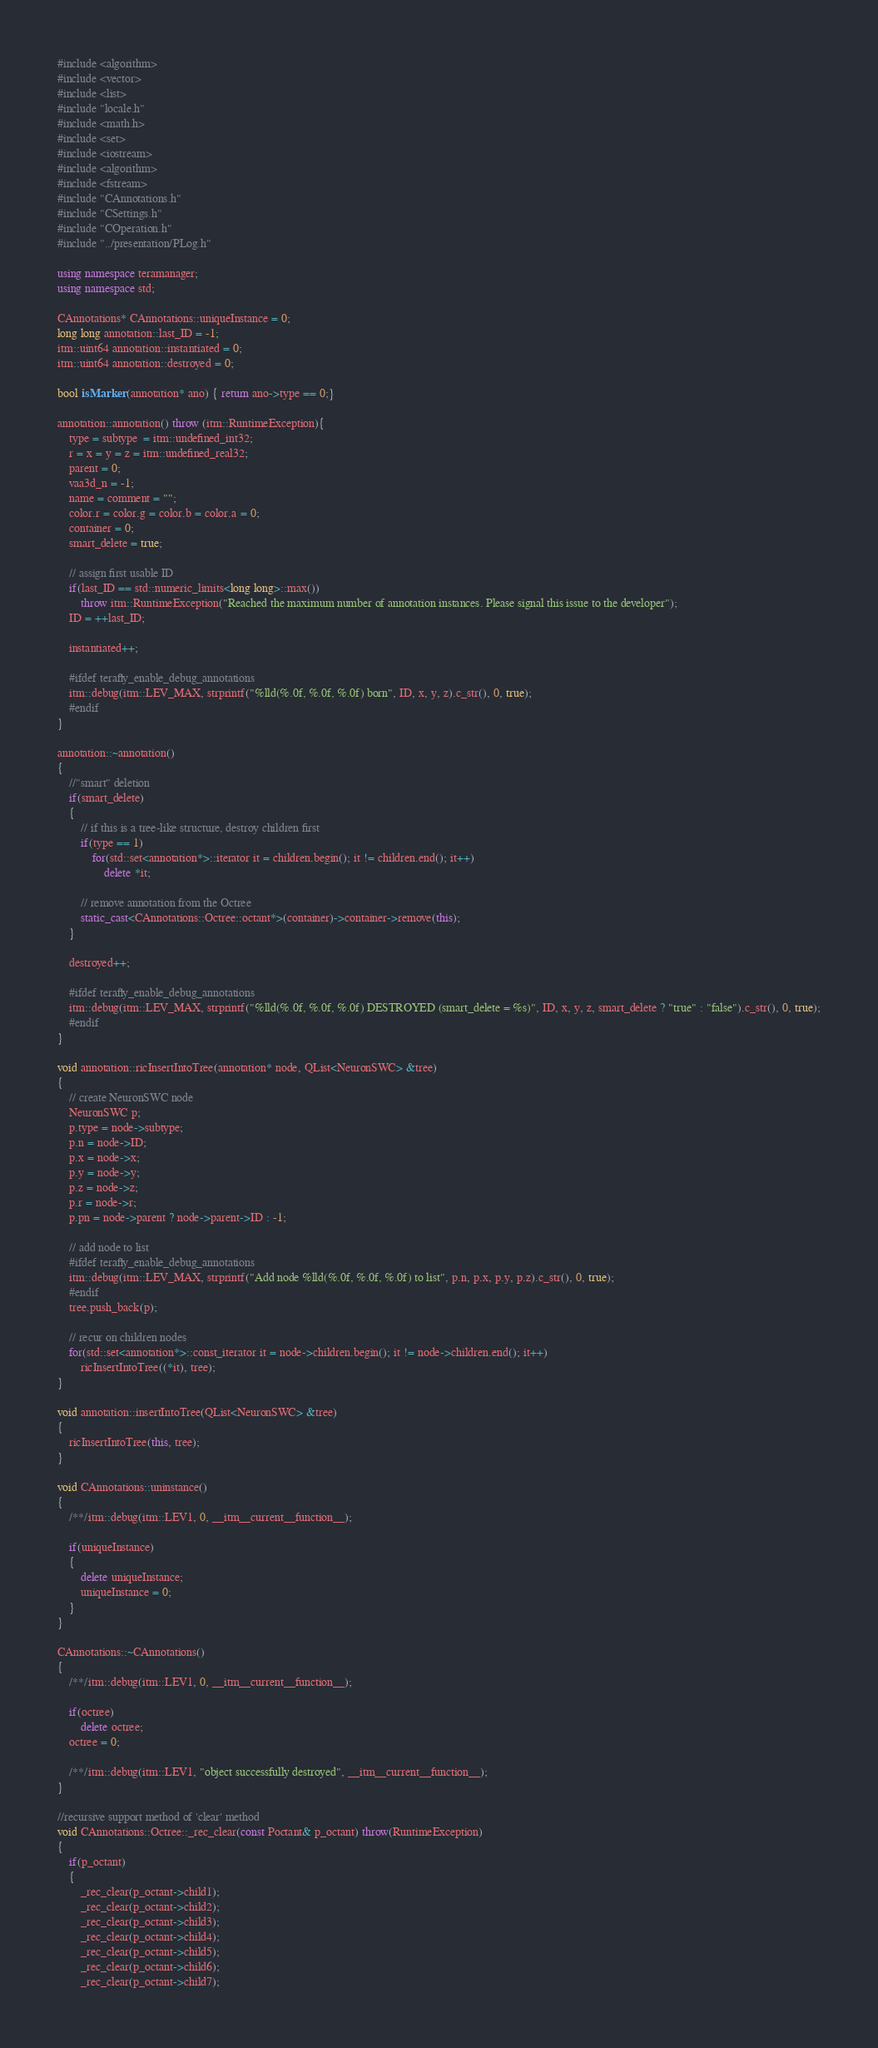<code> <loc_0><loc_0><loc_500><loc_500><_C++_>#include <algorithm>
#include <vector>
#include <list>
#include "locale.h"
#include <math.h>
#include <set>
#include <iostream>
#include <algorithm>
#include <fstream>
#include "CAnnotations.h"
#include "CSettings.h"
#include "COperation.h"
#include "../presentation/PLog.h"

using namespace teramanager;
using namespace std;

CAnnotations* CAnnotations::uniqueInstance = 0;
long long annotation::last_ID = -1;
itm::uint64 annotation::instantiated = 0;
itm::uint64 annotation::destroyed = 0;

bool isMarker (annotation* ano) { return ano->type == 0;}

annotation::annotation() throw (itm::RuntimeException){
    type = subtype  = itm::undefined_int32;
    r = x = y = z = itm::undefined_real32;
    parent = 0;
    vaa3d_n = -1;
    name = comment = "";
    color.r = color.g = color.b = color.a = 0;
    container = 0;
    smart_delete = true;

    // assign first usable ID
    if(last_ID == std::numeric_limits<long long>::max())
        throw itm::RuntimeException("Reached the maximum number of annotation instances. Please signal this issue to the developer");
    ID = ++last_ID;

    instantiated++;

    #ifdef terafly_enable_debug_annotations
    itm::debug(itm::LEV_MAX, strprintf("%lld(%.0f, %.0f, %.0f) born", ID, x, y, z).c_str(), 0, true);
    #endif
}

annotation::~annotation()
{
    //"smart" deletion
    if(smart_delete)
    {
        // if this is a tree-like structure, destroy children first
        if(type == 1)
            for(std::set<annotation*>::iterator it = children.begin(); it != children.end(); it++)
                delete *it;

        // remove annotation from the Octree
        static_cast<CAnnotations::Octree::octant*>(container)->container->remove(this);
    }

    destroyed++;

    #ifdef terafly_enable_debug_annotations
    itm::debug(itm::LEV_MAX, strprintf("%lld(%.0f, %.0f, %.0f) DESTROYED (smart_delete = %s)", ID, x, y, z, smart_delete ? "true" : "false").c_str(), 0, true);
    #endif
}

void annotation::ricInsertIntoTree(annotation* node, QList<NeuronSWC> &tree)
{
    // create NeuronSWC node
    NeuronSWC p;
    p.type = node->subtype;
    p.n = node->ID;
    p.x = node->x;
    p.y = node->y;
    p.z = node->z;
    p.r = node->r;
    p.pn = node->parent ? node->parent->ID : -1;

    // add node to list
    #ifdef terafly_enable_debug_annotations
    itm::debug(itm::LEV_MAX, strprintf("Add node %lld(%.0f, %.0f, %.0f) to list", p.n, p.x, p.y, p.z).c_str(), 0, true);
    #endif
    tree.push_back(p);

    // recur on children nodes
    for(std::set<annotation*>::const_iterator it = node->children.begin(); it != node->children.end(); it++)
        ricInsertIntoTree((*it), tree);
}

void annotation::insertIntoTree(QList<NeuronSWC> &tree)
{
    ricInsertIntoTree(this, tree);
}

void CAnnotations::uninstance()
{
    /**/itm::debug(itm::LEV1, 0, __itm__current__function__);

    if(uniqueInstance)
    {
        delete uniqueInstance;
        uniqueInstance = 0;
    }
}

CAnnotations::~CAnnotations()
{
    /**/itm::debug(itm::LEV1, 0, __itm__current__function__);

    if(octree)
        delete octree;
    octree = 0;

    /**/itm::debug(itm::LEV1, "object successfully destroyed", __itm__current__function__);
}

//recursive support method of 'clear' method
void CAnnotations::Octree::_rec_clear(const Poctant& p_octant) throw(RuntimeException)
{
    if(p_octant)
    {
        _rec_clear(p_octant->child1);
        _rec_clear(p_octant->child2);
        _rec_clear(p_octant->child3);
        _rec_clear(p_octant->child4);
        _rec_clear(p_octant->child5);
        _rec_clear(p_octant->child6);
        _rec_clear(p_octant->child7);</code> 